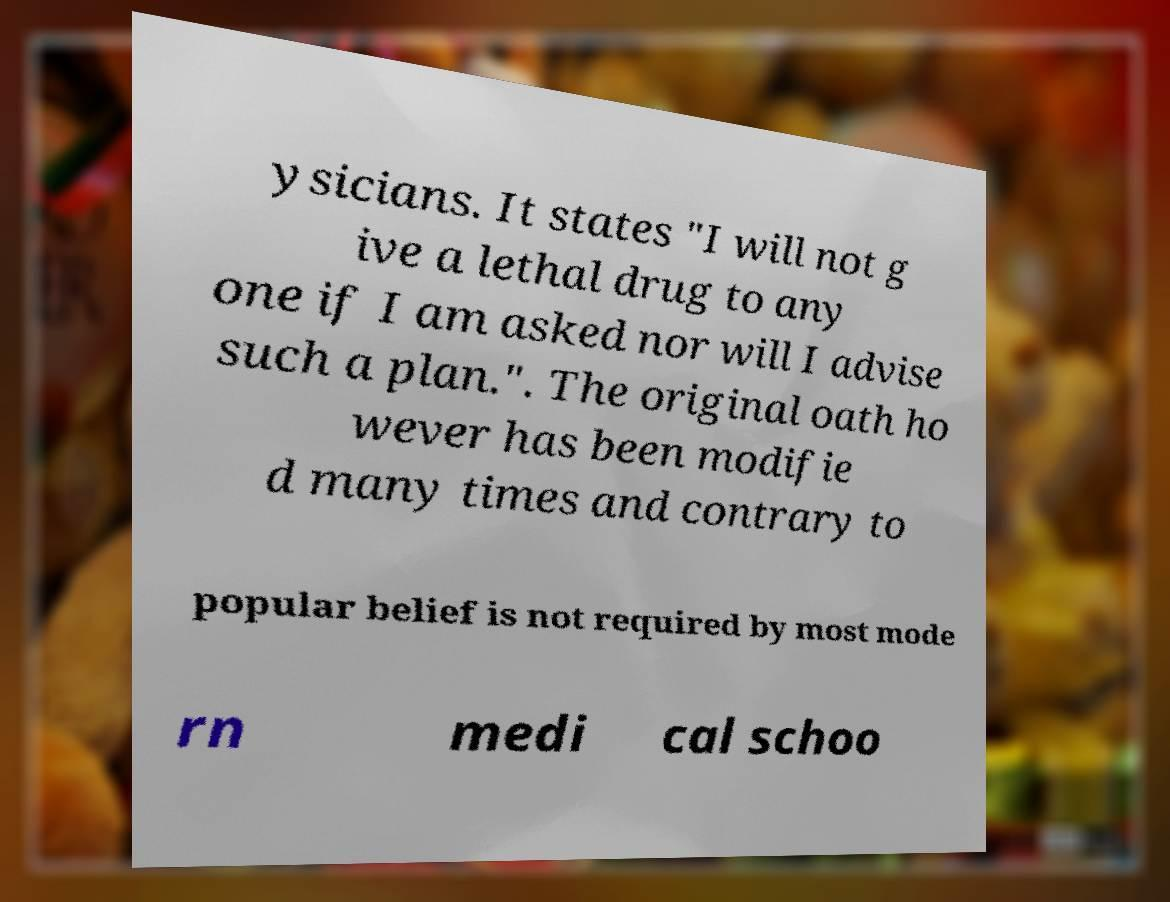Please identify and transcribe the text found in this image. ysicians. It states "I will not g ive a lethal drug to any one if I am asked nor will I advise such a plan.". The original oath ho wever has been modifie d many times and contrary to popular belief is not required by most mode rn medi cal schoo 